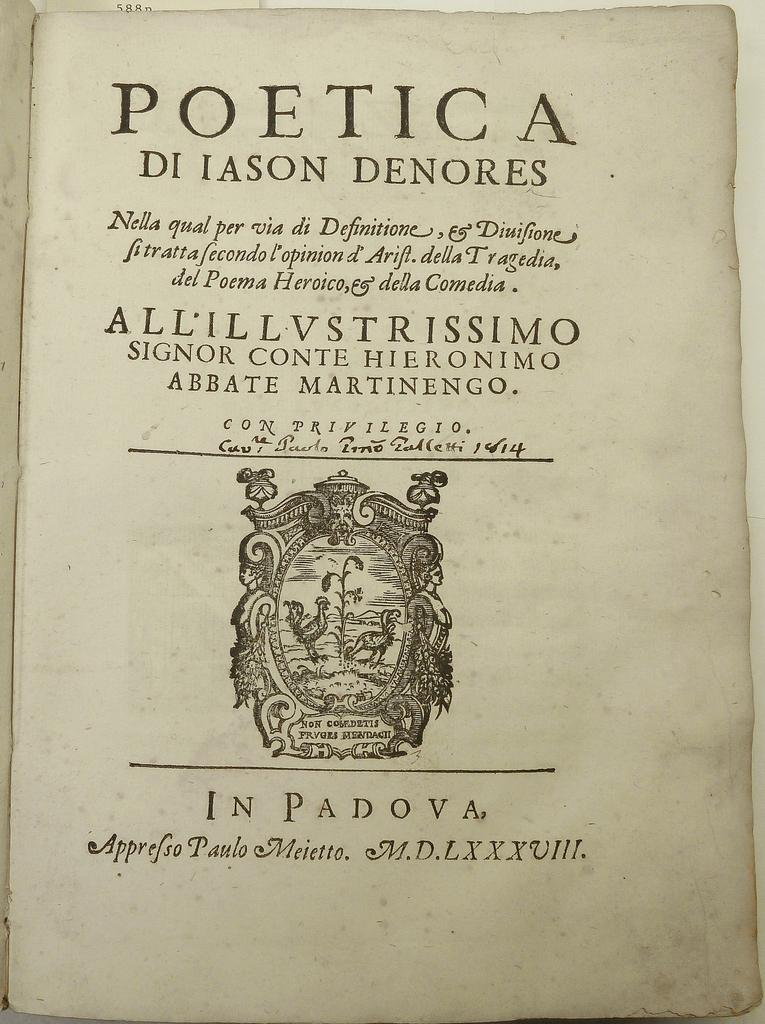<image>
Present a compact description of the photo's key features. A book called the Poetica Di Jason Denores 